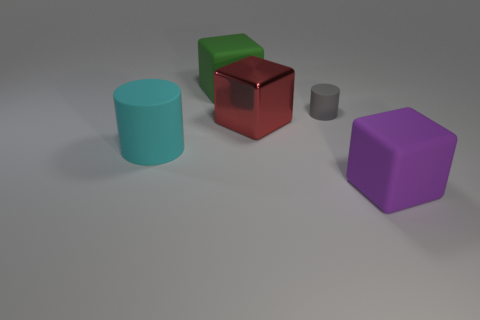Add 2 cylinders. How many objects exist? 7 Subtract all cylinders. How many objects are left? 3 Subtract all rubber things. Subtract all blue cylinders. How many objects are left? 1 Add 3 tiny matte cylinders. How many tiny matte cylinders are left? 4 Add 4 small cyan shiny cubes. How many small cyan shiny cubes exist? 4 Subtract 0 yellow cylinders. How many objects are left? 5 